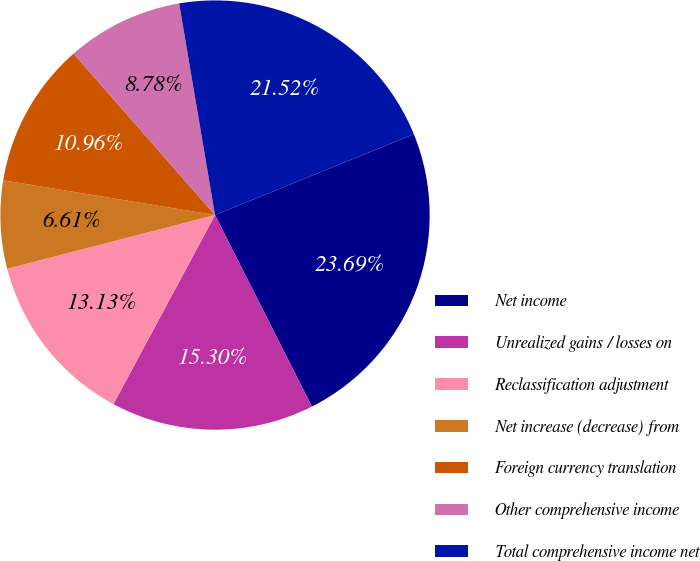Convert chart to OTSL. <chart><loc_0><loc_0><loc_500><loc_500><pie_chart><fcel>Net income<fcel>Unrealized gains / losses on<fcel>Reclassification adjustment<fcel>Net increase (decrease) from<fcel>Foreign currency translation<fcel>Other comprehensive income<fcel>Total comprehensive income net<nl><fcel>23.69%<fcel>15.3%<fcel>13.13%<fcel>6.61%<fcel>10.96%<fcel>8.78%<fcel>21.52%<nl></chart> 